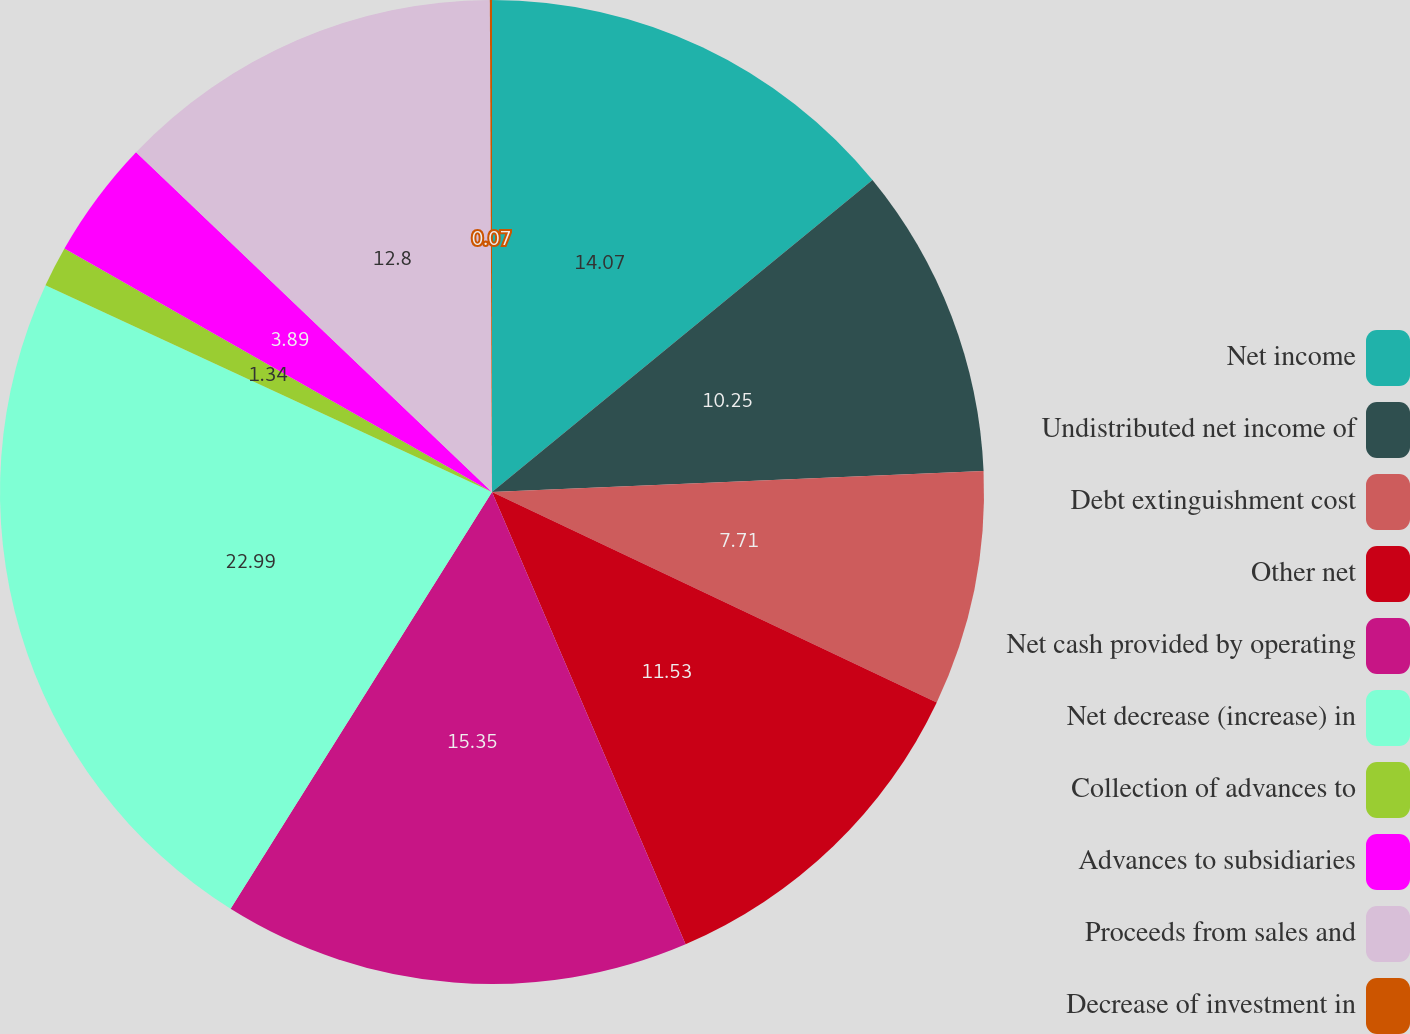<chart> <loc_0><loc_0><loc_500><loc_500><pie_chart><fcel>Net income<fcel>Undistributed net income of<fcel>Debt extinguishment cost<fcel>Other net<fcel>Net cash provided by operating<fcel>Net decrease (increase) in<fcel>Collection of advances to<fcel>Advances to subsidiaries<fcel>Proceeds from sales and<fcel>Decrease of investment in<nl><fcel>14.07%<fcel>10.25%<fcel>7.71%<fcel>11.53%<fcel>15.35%<fcel>22.98%<fcel>1.34%<fcel>3.89%<fcel>12.8%<fcel>0.07%<nl></chart> 